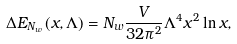<formula> <loc_0><loc_0><loc_500><loc_500>\Delta E _ { N _ { w } } \left ( x , \Lambda \right ) = N _ { w } \frac { V } { 3 2 \pi ^ { 2 } } \Lambda ^ { 4 } x ^ { 2 } \ln x ,</formula> 